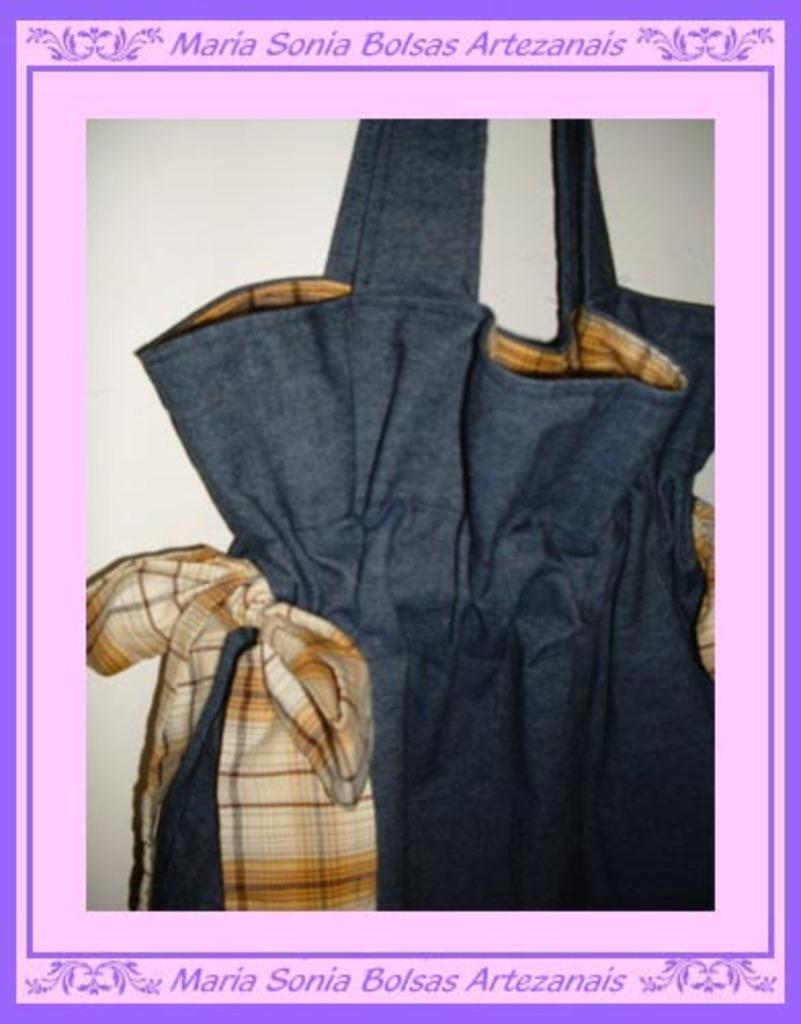What type of medium is the image? The image is a poster. What material is featured on the poster? The poster contains cloth. Can you see a kitten using a quill to write on the cloth in the poster? No, there is no kitten or quill present in the poster; it only contains cloth. 